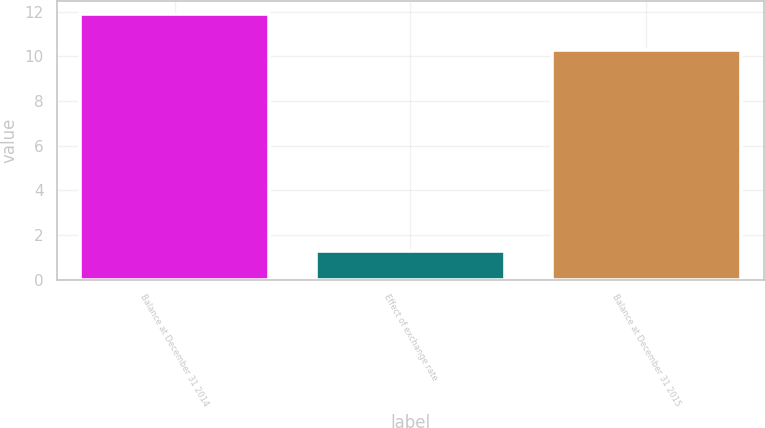Convert chart to OTSL. <chart><loc_0><loc_0><loc_500><loc_500><bar_chart><fcel>Balance at December 31 2014<fcel>Effect of exchange rate<fcel>Balance at December 31 2015<nl><fcel>11.9<fcel>1.3<fcel>10.3<nl></chart> 